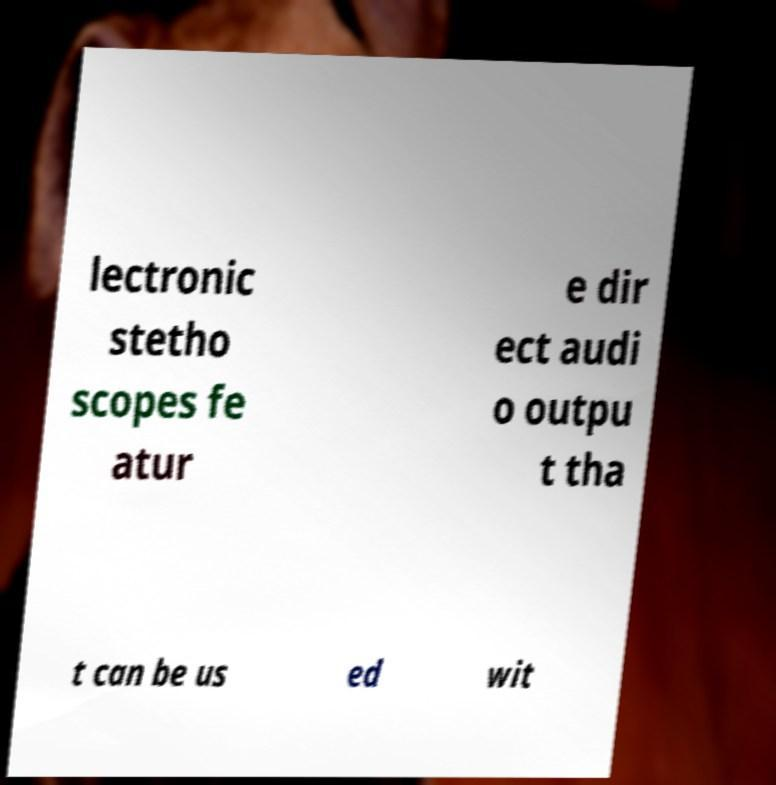What messages or text are displayed in this image? I need them in a readable, typed format. lectronic stetho scopes fe atur e dir ect audi o outpu t tha t can be us ed wit 